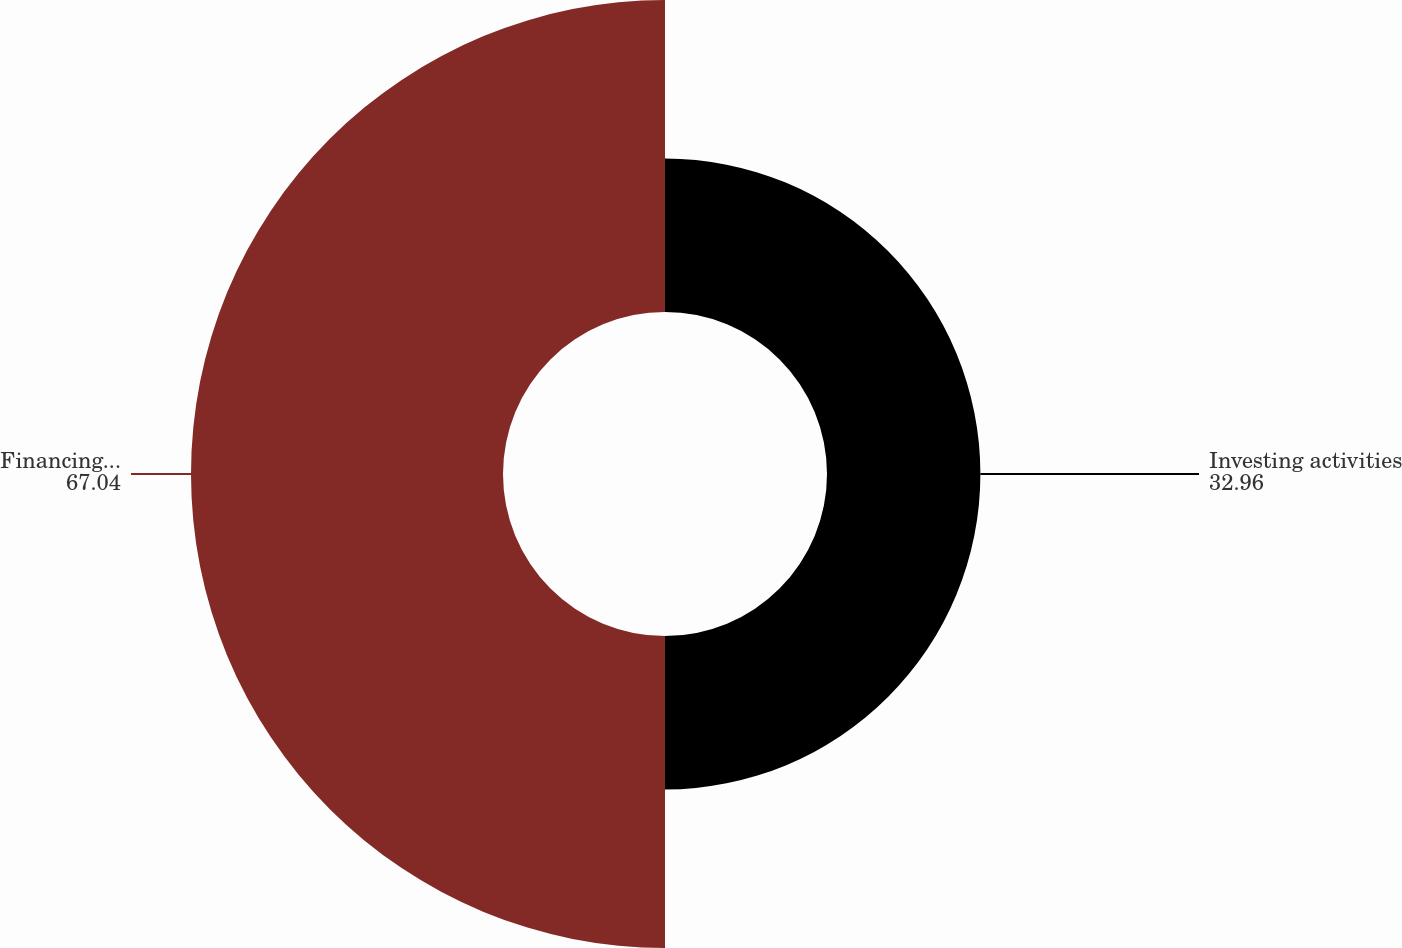Convert chart to OTSL. <chart><loc_0><loc_0><loc_500><loc_500><pie_chart><fcel>Investing activities<fcel>Financing activities<nl><fcel>32.96%<fcel>67.04%<nl></chart> 